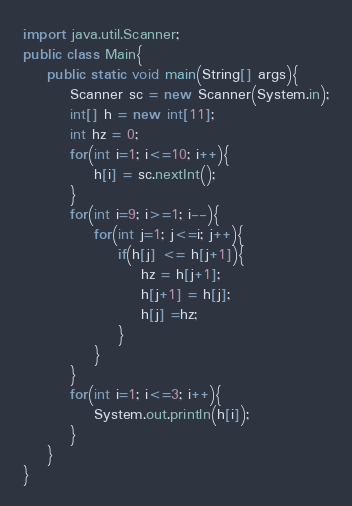<code> <loc_0><loc_0><loc_500><loc_500><_Java_>import java.util.Scanner;
public class Main{
	public static void main(String[] args){
		Scanner sc = new Scanner(System.in);
		int[] h = new int[11];
		int hz = 0;
		for(int i=1; i<=10; i++){
			h[i] = sc.nextInt();
		}
		for(int i=9; i>=1; i--){
			for(int j=1; j<=i; j++){
				if(h[j] <= h[j+1]){
					hz = h[j+1];
					h[j+1] = h[j];
					h[j] =hz;
				}
			}
		}
		for(int i=1; i<=3; i++){
			System.out.println(h[i]);
		}
	}
}</code> 